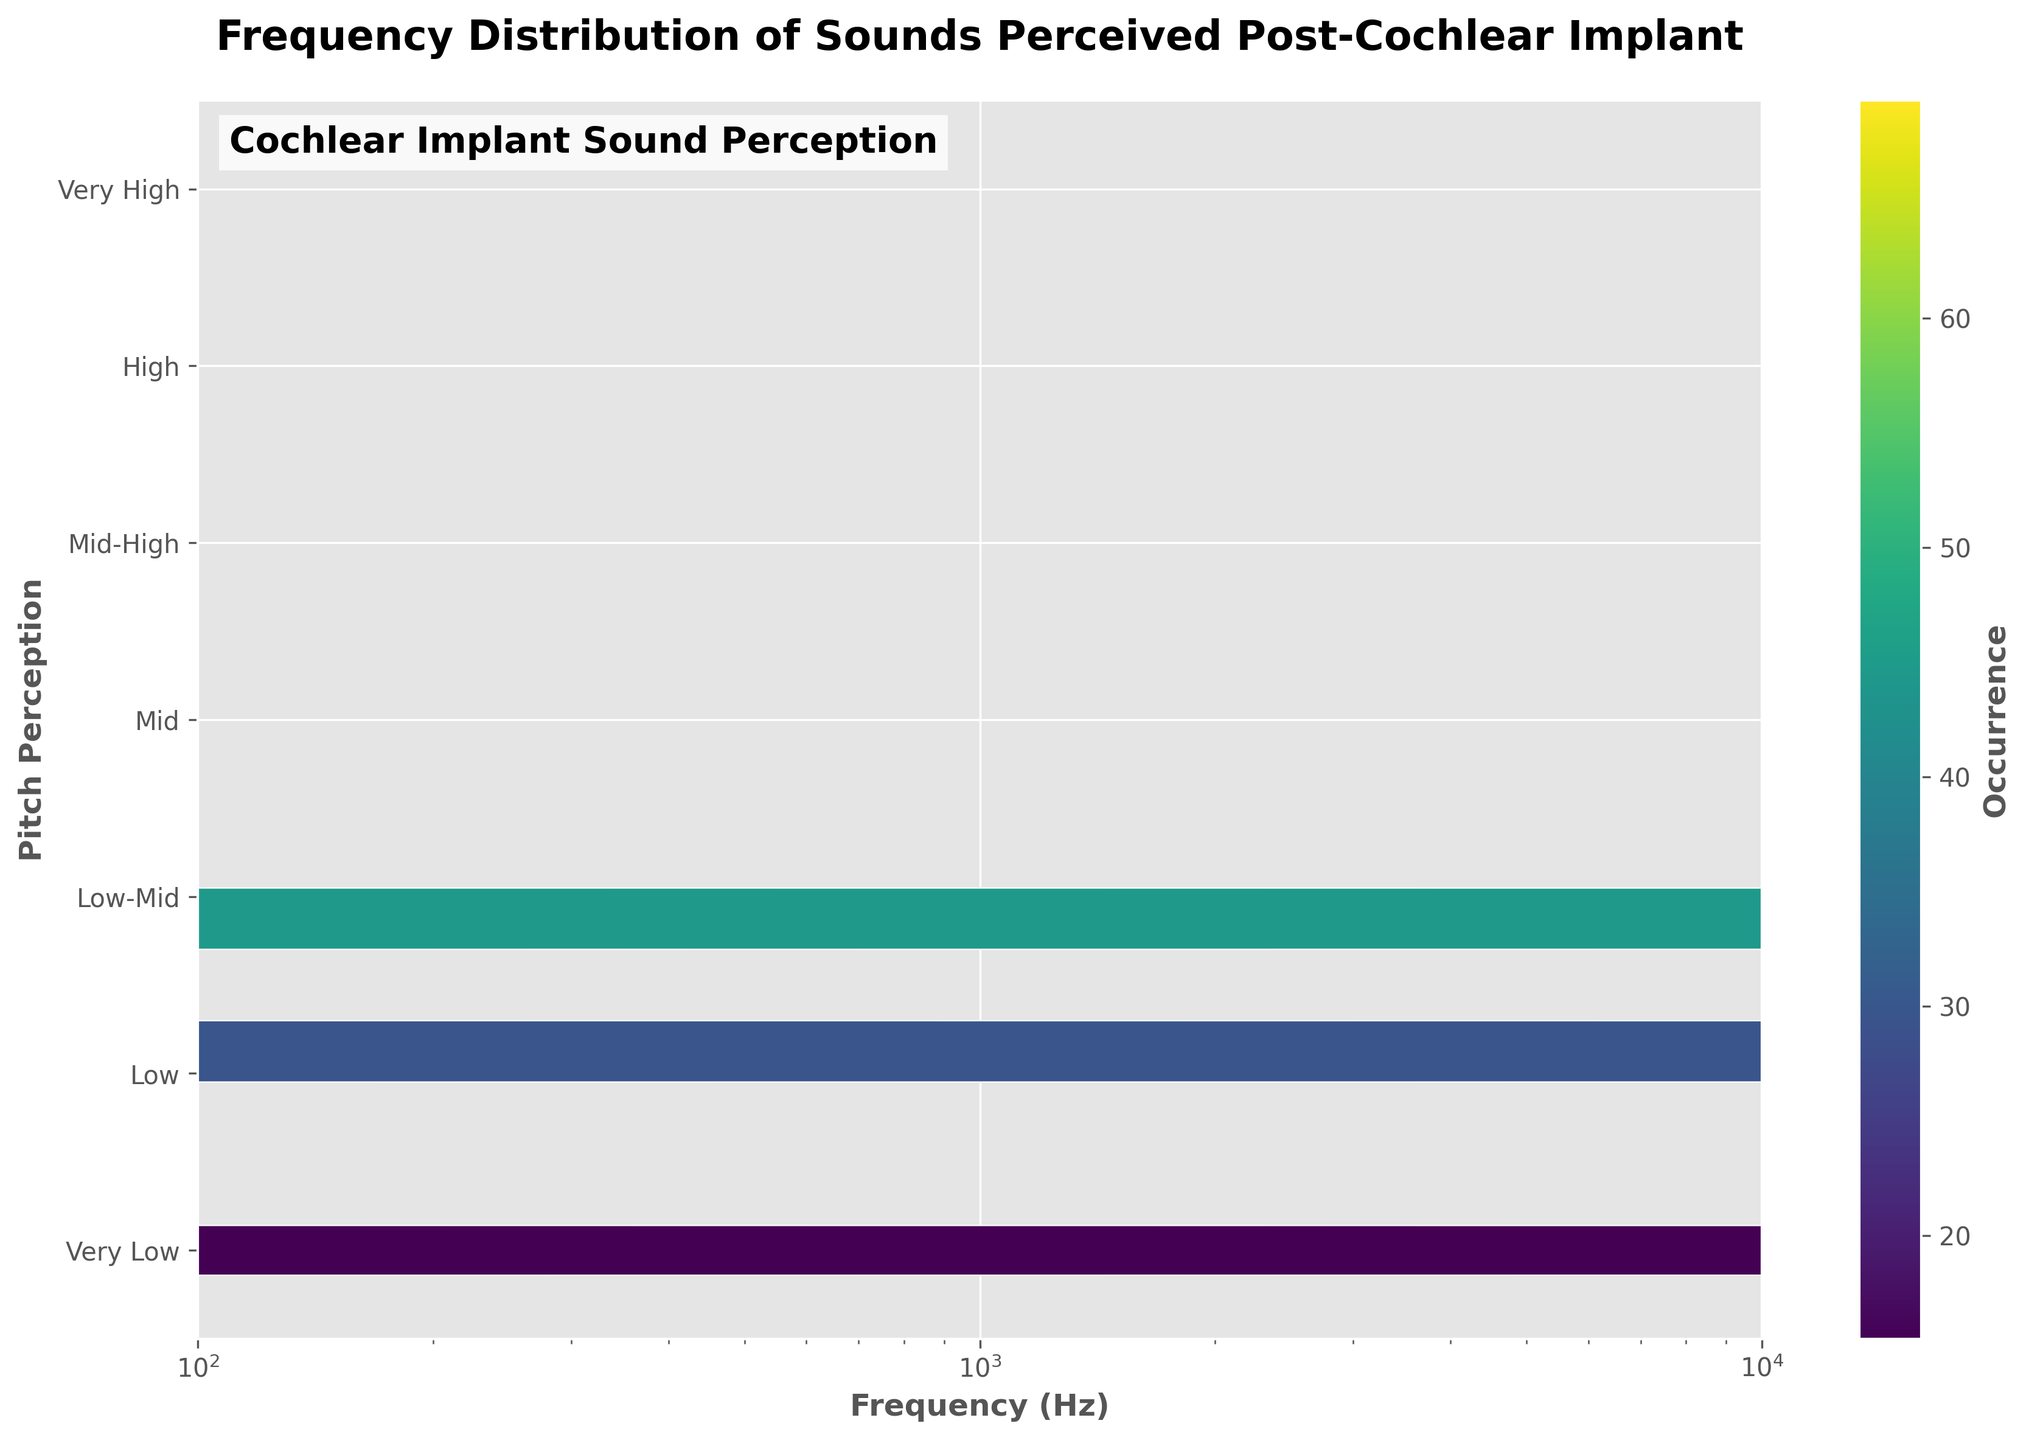How is the distribution of occurrences across the different pitch perceptions? By observing the color intensity in the hexbin plot, we can see that the 'Mid' pitch perception has the highest concentration of occurrences, followed by 'Mid-High', 'High', and 'Low-Mid'. The 'Very Low', 'Low', and 'Very High' categories have lower occurrences.
Answer: 'Mid' has the highest, followed by 'Mid-High', 'High', and 'Low-Mid' What is the maximum frequency range shown in the plot? The x-axis of the plot is on a logarithmic scale, ranging from 100 Hz to 10000 Hz.
Answer: 100 Hz to 10000 Hz Which pitch perception category has the most localized distribution of frequency? Observing the concentration of hexagons, the 'Mid' pitch perception is the most concentrated around the mid frequencies (1000 Hz), indicating a localized distribution.
Answer: 'Mid' Is there any pitch perception that seems evenly spread across a wide frequency range? The 'Very Low' and 'Very High' categories seem to be more evenly distributed across their respective frequency ranges compared to other categories.
Answer: 'Very Low' and 'Very High' Which frequency range appears to have the highest overall occurrences? The hexbin plot shows the highest overall occurrences in the range around 1000 Hz, which aligns with the 'Mid' pitch perception.
Answer: Around 1000 Hz How does the occurrence of the 'High' pitch perception compare to 'Low-Mid' pitch perception? By comparing the color density of 'High' and 'Low-Mid' pitch perceptions in the hexbin plot, 'Low-Mid' has a slightly higher density, indicating more occurrences.
Answer: 'Low-Mid' has more occurrences What can you infer about the relationship between frequency and pitch perception from this plot? The hexbin plot indicates that as frequency increases, pitch perception tends to shift from 'Very Low' to 'Very High'. There is a notable peak in the middle frequencies correlating with 'Mid' and 'Mid-High' pitch perceptions.
Answer: Frequency increases correlate with higher pitch perceptions Which pitch perception is most frequent at approximately 500 Hz? The plot shows that the 'Low-Mid' pitch perception is most frequent around the 500 Hz frequency range, indicated by the color density.
Answer: 'Low-Mid' How does the color bar help in interpreting the occurrences of sound perception? The color bar on the hexbin plot provides a reference for the number of occurrences, with darker colors indicating higher occurrences. This helps to visually identify areas with higher and lower occurrences of sound perception across different frequencies and pitch perceptions.
Answer: Indicates number of occurrences Which pitch perception category has the least occurrences? The 'Very High' pitch perception category has the least occurrences among the categorized pitch perceptions, based on the color density shown in the hexbin plot.
Answer: 'Very High' 